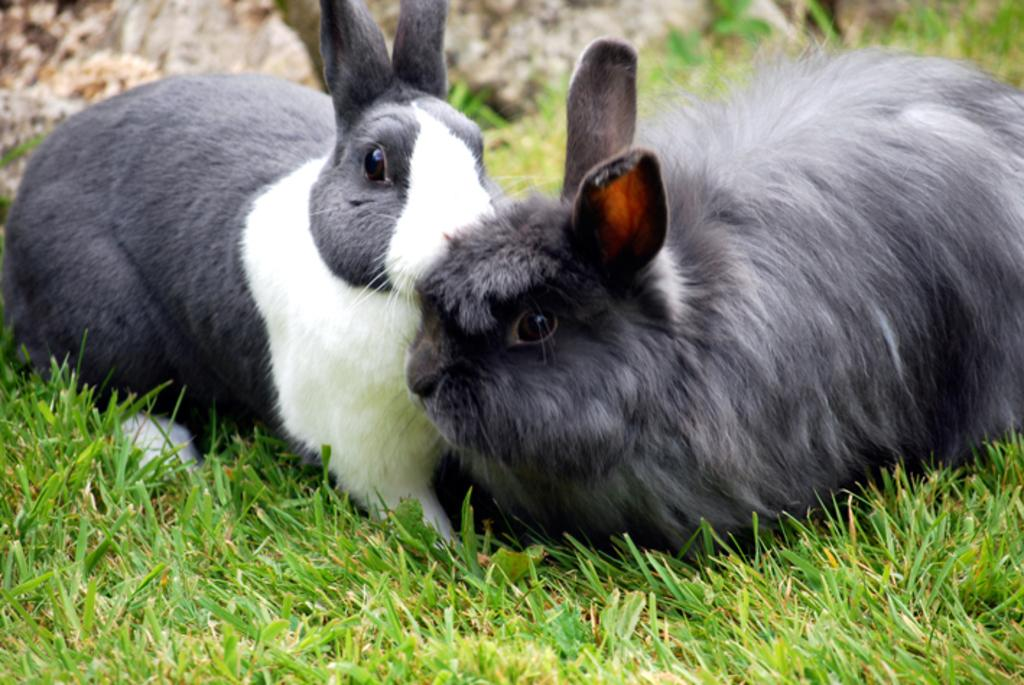How many rabbits are in the picture? There are two rabbits in the picture. What are the rabbits doing in the picture? The rabbits are sitting on the grass. What time is displayed on the rabbits' fingers in the image? There are no watches or clocks visible on the rabbits' fingers in the image. 